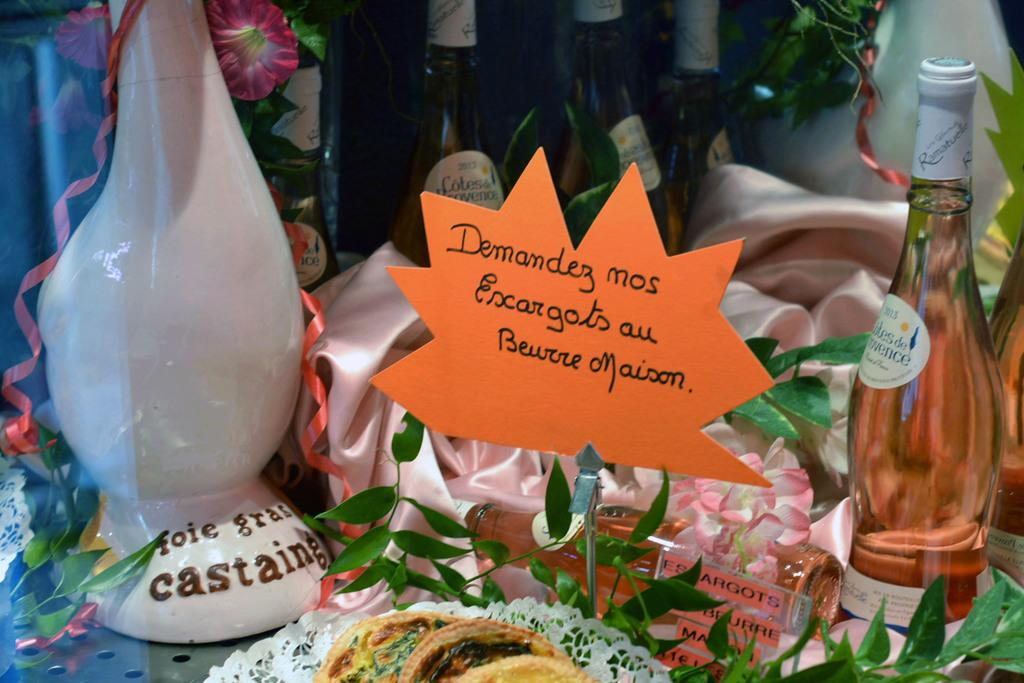Provide a one-sentence caption for the provided image. A sign hand written in French accompanies several bottles of wine. 